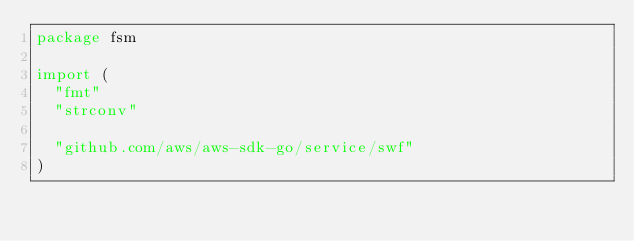Convert code to text. <code><loc_0><loc_0><loc_500><loc_500><_Go_>package fsm

import (
	"fmt"
	"strconv"

	"github.com/aws/aws-sdk-go/service/swf"
)
</code> 